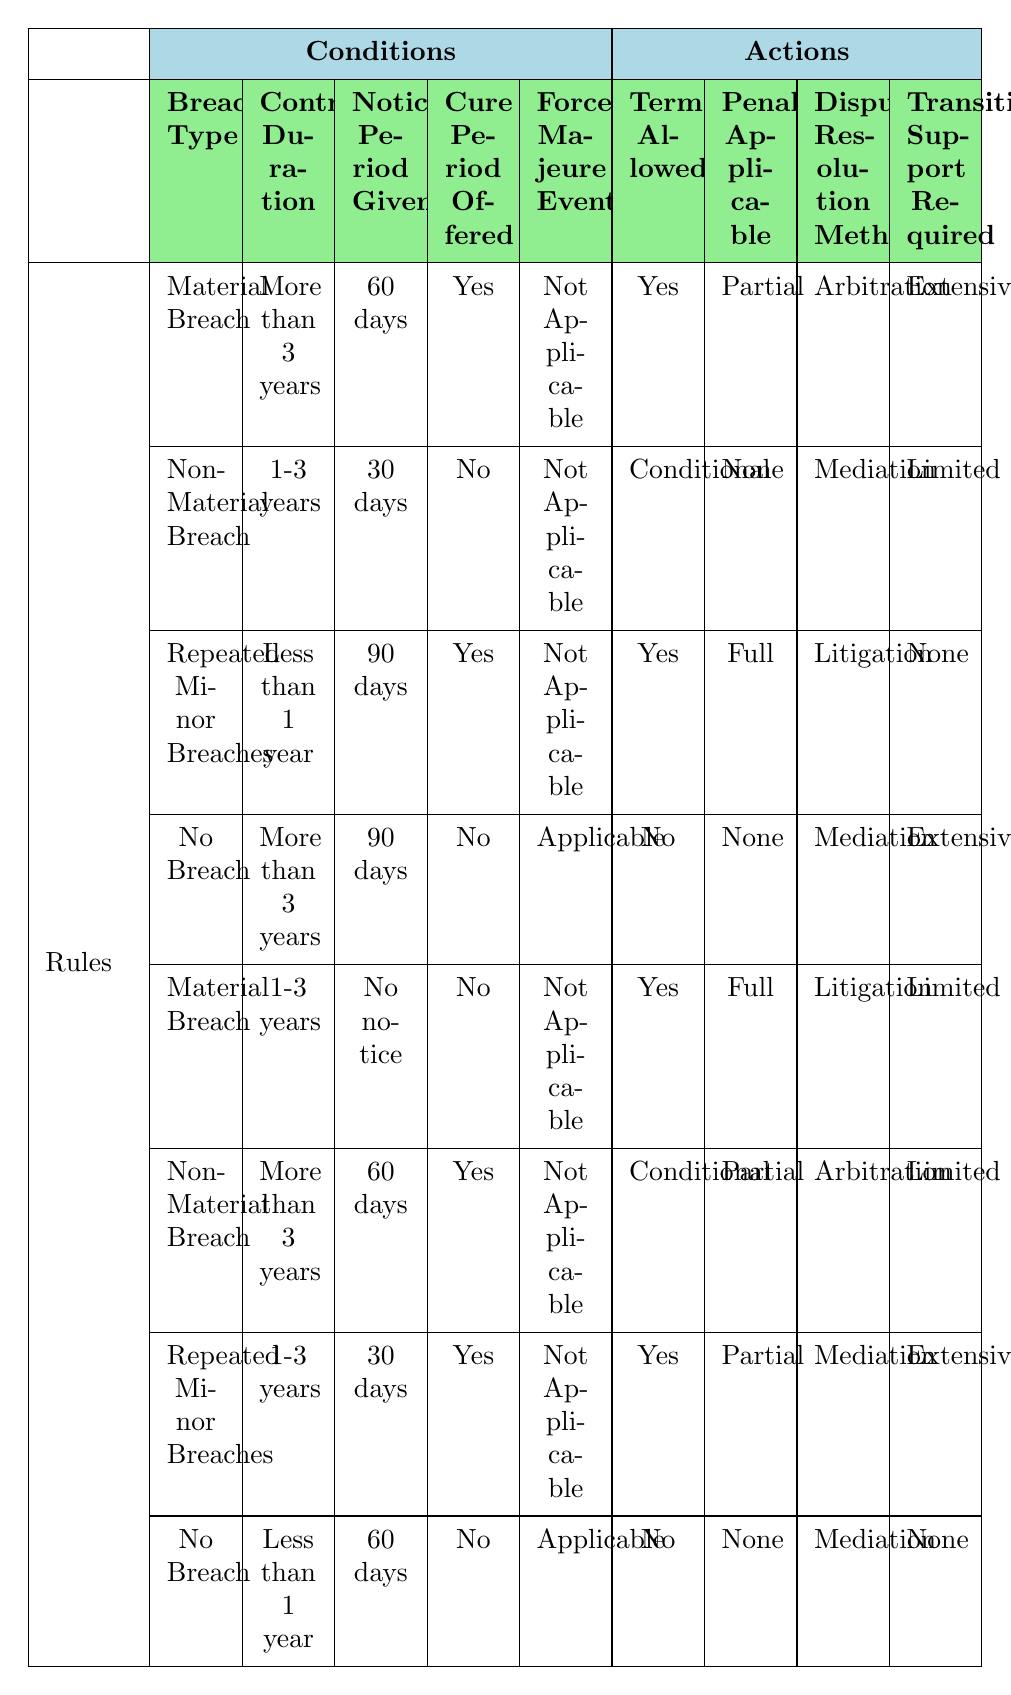What is the termination allowed status for a material breach with a contract duration of more than 3 years, with a 60-day notice? According to the table, when the breach type is "Material Breach," the contract duration is "More than 3 years," the notice period is "60 days," the cure period is "Yes," and the force majeure event is "Not Applicable," the termination allowed status is "Yes."
Answer: Yes Is there a penalty applicable for non-material breaches lasting 1-3 years with no notice? The table indicates that for a "Non-Material Breach" with a contract duration of "1-3 years," a "30 days" notice, and "No" cure offered, the penalty applicable is "None."
Answer: None For repeated minor breaches that last less than 1 year with a 90-day notice, what type of dispute resolution method is proposed? From the rules, for "Repeated Minor Breaches" with "Less than 1 year," a "90 days" notice, "Yes" cure offered, and "Not Applicable" force majeure, the dispute resolution method suggested is "Litigation."
Answer: Litigation What is the transition support required when there is no breach for a contract duration of less than 1 year with a 60-day notice period? The table specifies that if there is "No Breach" with "Less than 1 year" duration and a "60 days" notice, the required transition support is "None."
Answer: None How many conditions must be "Yes" to allow termination for a material breach with no cure period offered in a contract duration of 1-3 years and no notice given? In this case, the conditions are "Material Breach," "1-3 years," "No notice," "No" cure offered, and "Not Applicable." Here, termination is allowed with "Yes," but the cure period being "No" means only one condition is fulfilled definitively, so termination is allowed. Thus, only one "Yes" condition is strictly needed in this scenario.
Answer: 1 If a non-material breach is observed for a contract duration of over 3 years with a 60-day notice, what is the penalty applicable and the dispute resolution method? The specific case indicates, for "Non-Material Breach," "More than 3 years," "60 days" notice, and "Yes" cure offered, the penalty applicable is "Partial," and the dispute resolution method is "Arbitration." This can be examined by checking the relevant row in the table.
Answer: Partial, Arbitration 